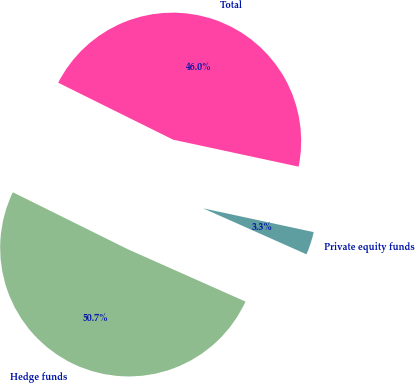Convert chart to OTSL. <chart><loc_0><loc_0><loc_500><loc_500><pie_chart><fcel>Hedge funds<fcel>Private equity funds<fcel>Total<nl><fcel>50.66%<fcel>3.29%<fcel>46.05%<nl></chart> 